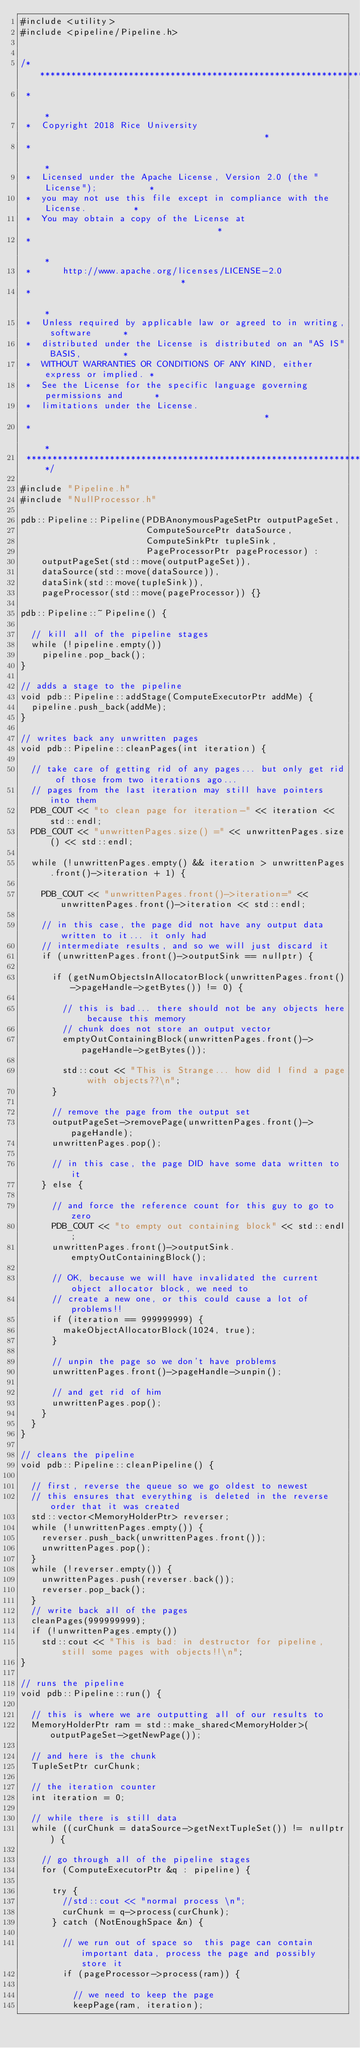Convert code to text. <code><loc_0><loc_0><loc_500><loc_500><_C++_>#include <utility>
#include <pipeline/Pipeline.h>


/*****************************************************************************
 *                                                                           *
 *  Copyright 2018 Rice University                                           *
 *                                                                           *
 *  Licensed under the Apache License, Version 2.0 (the "License");          *
 *  you may not use this file except in compliance with the License.         *
 *  You may obtain a copy of the License at                                  *
 *                                                                           *
 *      http://www.apache.org/licenses/LICENSE-2.0                           *
 *                                                                           *
 *  Unless required by applicable law or agreed to in writing, software      *
 *  distributed under the License is distributed on an "AS IS" BASIS,        *
 *  WITHOUT WARRANTIES OR CONDITIONS OF ANY KIND, either express or implied. *
 *  See the License for the specific language governing permissions and      *
 *  limitations under the License.                                           *
 *                                                                           *
 *****************************************************************************/

#include "Pipeline.h"
#include "NullProcessor.h"

pdb::Pipeline::Pipeline(PDBAnonymousPageSetPtr outputPageSet,
                        ComputeSourcePtr dataSource,
                        ComputeSinkPtr tupleSink,
                        PageProcessorPtr pageProcessor) :
    outputPageSet(std::move(outputPageSet)),
    dataSource(std::move(dataSource)),
    dataSink(std::move(tupleSink)),
    pageProcessor(std::move(pageProcessor)) {}

pdb::Pipeline::~Pipeline() {

  // kill all of the pipeline stages
  while (!pipeline.empty())
    pipeline.pop_back();
}

// adds a stage to the pipeline
void pdb::Pipeline::addStage(ComputeExecutorPtr addMe) {
  pipeline.push_back(addMe);
}

// writes back any unwritten pages
void pdb::Pipeline::cleanPages(int iteration) {

  // take care of getting rid of any pages... but only get rid of those from two iterations ago...
  // pages from the last iteration may still have pointers into them
  PDB_COUT << "to clean page for iteration-" << iteration << std::endl;
  PDB_COUT << "unwrittenPages.size() =" << unwrittenPages.size() << std::endl;

  while (!unwrittenPages.empty() && iteration > unwrittenPages.front()->iteration + 1) {

    PDB_COUT << "unwrittenPages.front()->iteration=" << unwrittenPages.front()->iteration << std::endl;

    // in this case, the page did not have any output data written to it... it only had
    // intermediate results, and so we will just discard it
    if (unwrittenPages.front()->outputSink == nullptr) {

      if (getNumObjectsInAllocatorBlock(unwrittenPages.front()->pageHandle->getBytes()) != 0) {

        // this is bad... there should not be any objects here because this memory
        // chunk does not store an output vector
        emptyOutContainingBlock(unwrittenPages.front()->pageHandle->getBytes());

        std::cout << "This is Strange... how did I find a page with objects??\n";
      }

      // remove the page from the output set
      outputPageSet->removePage(unwrittenPages.front()->pageHandle);
      unwrittenPages.pop();

      // in this case, the page DID have some data written to it
    } else {

      // and force the reference count for this guy to go to zero
      PDB_COUT << "to empty out containing block" << std::endl;
      unwrittenPages.front()->outputSink.emptyOutContainingBlock();

      // OK, because we will have invalidated the current object allocator block, we need to
      // create a new one, or this could cause a lot of problems!!
      if (iteration == 999999999) {
        makeObjectAllocatorBlock(1024, true);
      }

      // unpin the page so we don't have problems
      unwrittenPages.front()->pageHandle->unpin();

      // and get rid of him
      unwrittenPages.pop();
    }
  }
}

// cleans the pipeline
void pdb::Pipeline::cleanPipeline() {

  // first, reverse the queue so we go oldest to newest
  // this ensures that everything is deleted in the reverse order that it was created
  std::vector<MemoryHolderPtr> reverser;
  while (!unwrittenPages.empty()) {
    reverser.push_back(unwrittenPages.front());
    unwrittenPages.pop();
  }
  while (!reverser.empty()) {
    unwrittenPages.push(reverser.back());
    reverser.pop_back();
  }
  // write back all of the pages
  cleanPages(999999999);
  if (!unwrittenPages.empty())
    std::cout << "This is bad: in destructor for pipeline, still some pages with objects!!\n";
}

// runs the pipeline
void pdb::Pipeline::run() {

  // this is where we are outputting all of our results to
  MemoryHolderPtr ram = std::make_shared<MemoryHolder>(outputPageSet->getNewPage());

  // and here is the chunk
  TupleSetPtr curChunk;

  // the iteration counter
  int iteration = 0;

  // while there is still data
  while ((curChunk = dataSource->getNextTupleSet()) != nullptr) {

    // go through all of the pipeline stages
    for (ComputeExecutorPtr &q : pipeline) {

      try {
        //std::cout << "normal process \n";
        curChunk = q->process(curChunk);
      } catch (NotEnoughSpace &n) {

        // we run out of space so  this page can contain important data, process the page and possibly store it
        if (pageProcessor->process(ram)) {

          // we need to keep the page
          keepPage(ram, iteration);</code> 